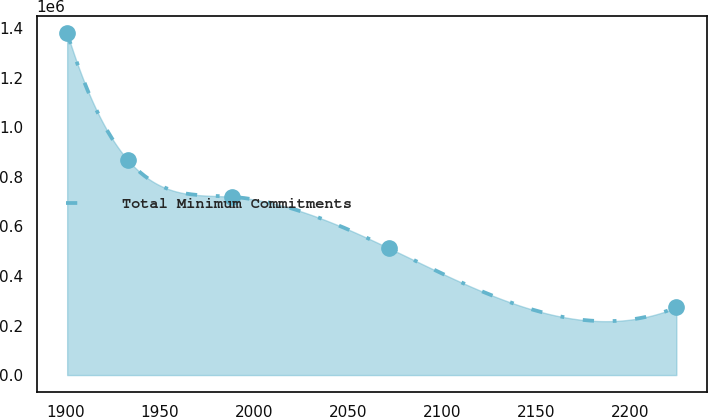Convert chart. <chart><loc_0><loc_0><loc_500><loc_500><line_chart><ecel><fcel>Total Minimum Commitments<nl><fcel>1901.03<fcel>1.37968e+06<nl><fcel>1933.36<fcel>866927<nl><fcel>1988.44<fcel>719570<nl><fcel>2071.93<fcel>511890<nl><fcel>2224.34<fcel>273314<nl></chart> 